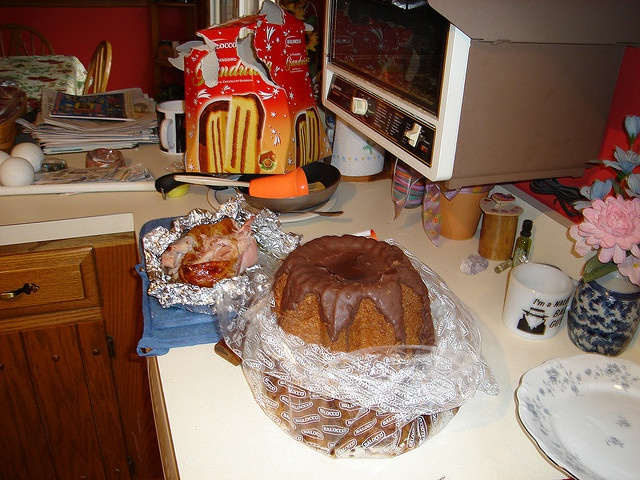Describe the objects in this image and their specific colors. I can see microwave in black, maroon, and gray tones, cake in black, maroon, lightgray, and brown tones, dining table in black, maroon, darkgreen, and gray tones, vase in black and gray tones, and cup in black, darkgray, and gray tones in this image. 